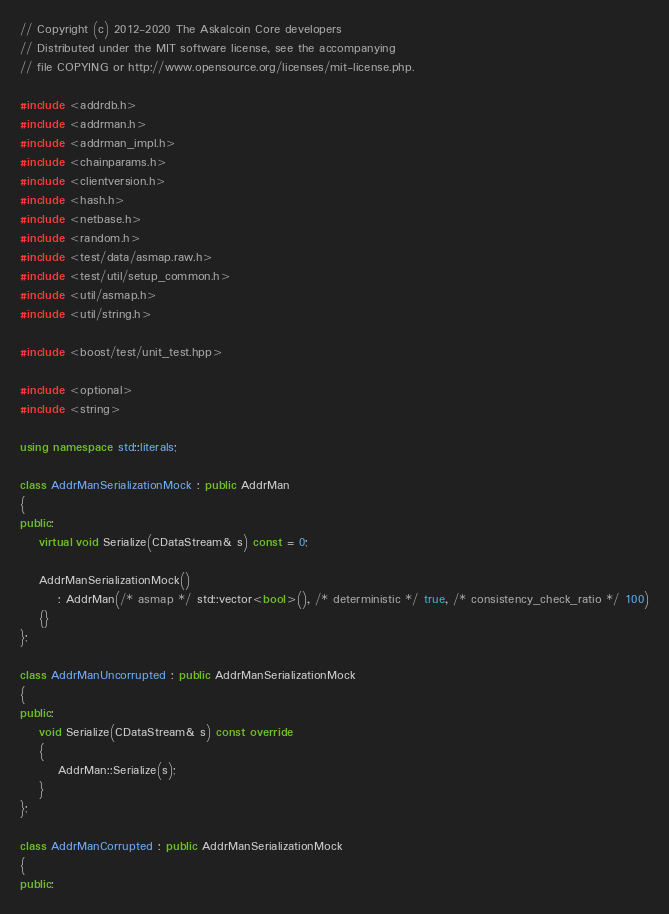Convert code to text. <code><loc_0><loc_0><loc_500><loc_500><_C++_>// Copyright (c) 2012-2020 The Askalcoin Core developers
// Distributed under the MIT software license, see the accompanying
// file COPYING or http://www.opensource.org/licenses/mit-license.php.

#include <addrdb.h>
#include <addrman.h>
#include <addrman_impl.h>
#include <chainparams.h>
#include <clientversion.h>
#include <hash.h>
#include <netbase.h>
#include <random.h>
#include <test/data/asmap.raw.h>
#include <test/util/setup_common.h>
#include <util/asmap.h>
#include <util/string.h>

#include <boost/test/unit_test.hpp>

#include <optional>
#include <string>

using namespace std::literals;

class AddrManSerializationMock : public AddrMan
{
public:
    virtual void Serialize(CDataStream& s) const = 0;

    AddrManSerializationMock()
        : AddrMan(/* asmap */ std::vector<bool>(), /* deterministic */ true, /* consistency_check_ratio */ 100)
    {}
};

class AddrManUncorrupted : public AddrManSerializationMock
{
public:
    void Serialize(CDataStream& s) const override
    {
        AddrMan::Serialize(s);
    }
};

class AddrManCorrupted : public AddrManSerializationMock
{
public:</code> 